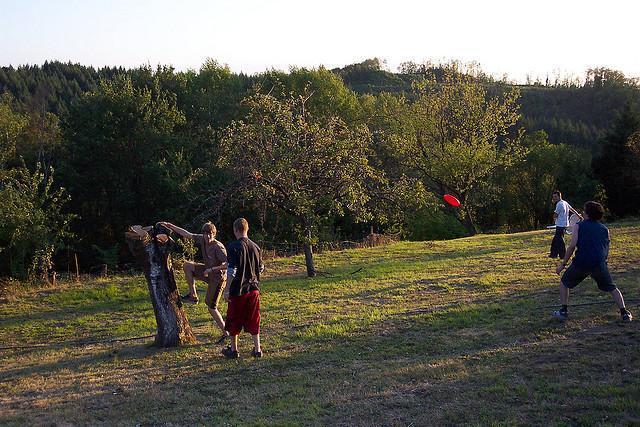How many people are in the picture?
Give a very brief answer. 3. How many dolphins are painted on the boats in this photo?
Give a very brief answer. 0. 